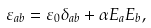<formula> <loc_0><loc_0><loc_500><loc_500>\varepsilon _ { a b } = \varepsilon _ { 0 } \delta _ { a b } + \alpha E _ { a } E _ { b } ,</formula> 